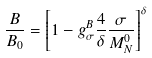Convert formula to latex. <formula><loc_0><loc_0><loc_500><loc_500>\frac { B } { B _ { 0 } } = \left [ 1 - g _ { \sigma } ^ { B } \frac { 4 } { \delta } \frac { \sigma } { M ^ { 0 } _ { N } } \right ] ^ { \delta }</formula> 